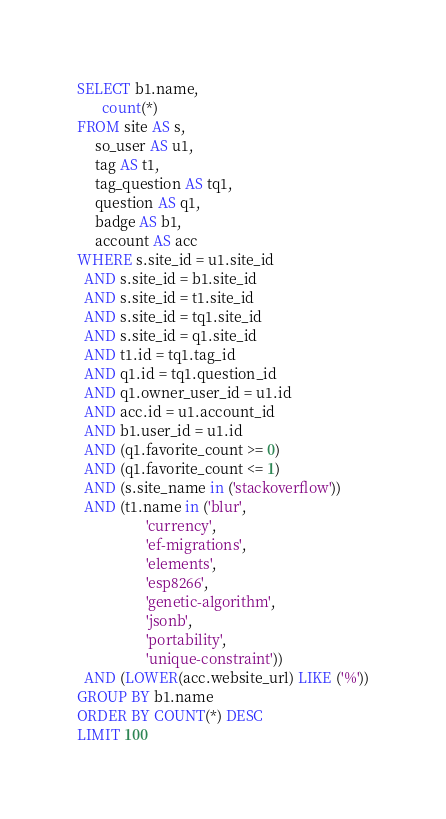<code> <loc_0><loc_0><loc_500><loc_500><_SQL_>SELECT b1.name,
       count(*)
FROM site AS s,
     so_user AS u1,
     tag AS t1,
     tag_question AS tq1,
     question AS q1,
     badge AS b1,
     account AS acc
WHERE s.site_id = u1.site_id
  AND s.site_id = b1.site_id
  AND s.site_id = t1.site_id
  AND s.site_id = tq1.site_id
  AND s.site_id = q1.site_id
  AND t1.id = tq1.tag_id
  AND q1.id = tq1.question_id
  AND q1.owner_user_id = u1.id
  AND acc.id = u1.account_id
  AND b1.user_id = u1.id
  AND (q1.favorite_count >= 0)
  AND (q1.favorite_count <= 1)
  AND (s.site_name in ('stackoverflow'))
  AND (t1.name in ('blur',
                   'currency',
                   'ef-migrations',
                   'elements',
                   'esp8266',
                   'genetic-algorithm',
                   'jsonb',
                   'portability',
                   'unique-constraint'))
  AND (LOWER(acc.website_url) LIKE ('%'))
GROUP BY b1.name
ORDER BY COUNT(*) DESC
LIMIT 100</code> 